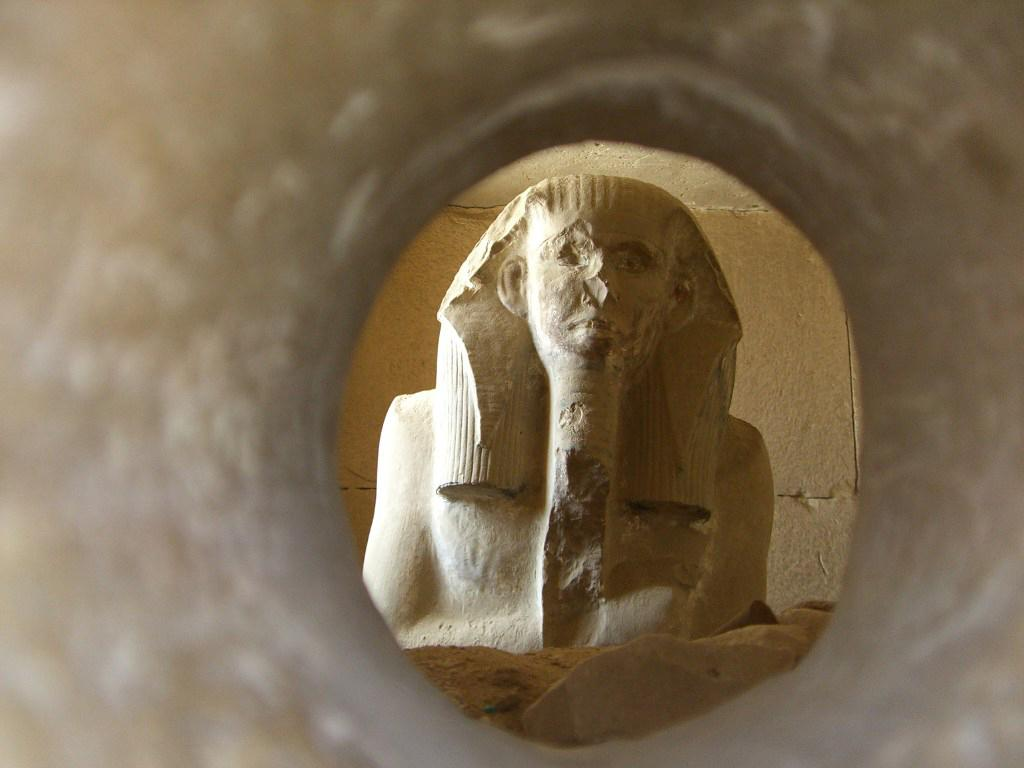What is the main subject of the image? There is a sculpture in the image. What material is present in the image? There is sand in the image. What color can be observed in the image? There are objects with a brown color in the image. What can be seen in the background of the image? There is a wall in the background of the image. What type of noise can be heard coming from the dock in the image? There is no dock present in the image, so it's not possible to determine what, if any, noise might be heard. 